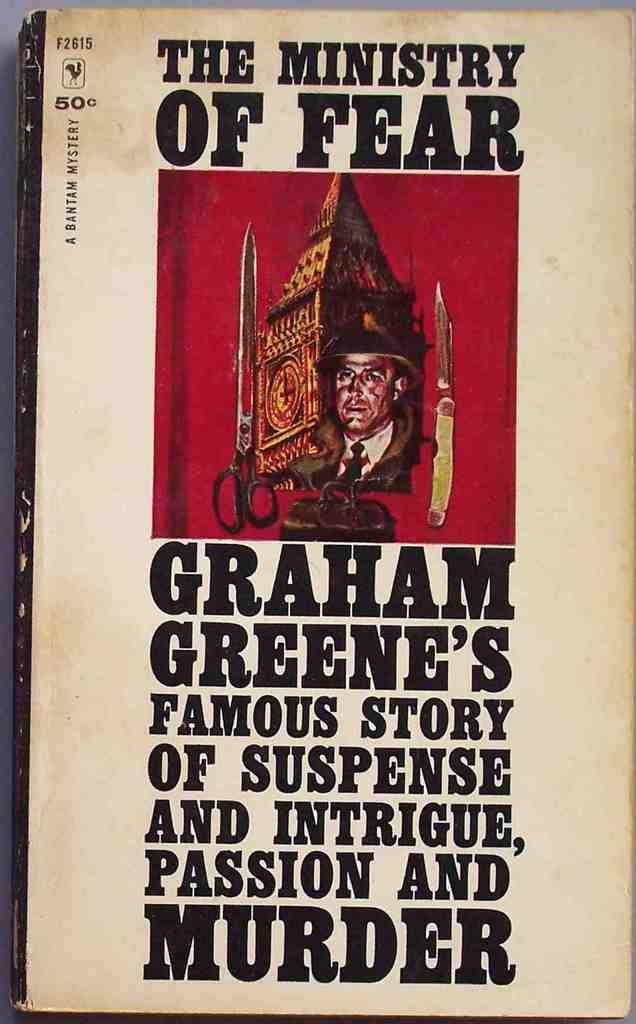<image>
Offer a succinct explanation of the picture presented. The cover of this book states that The Ministry Of Fear contains many elements including murder. 